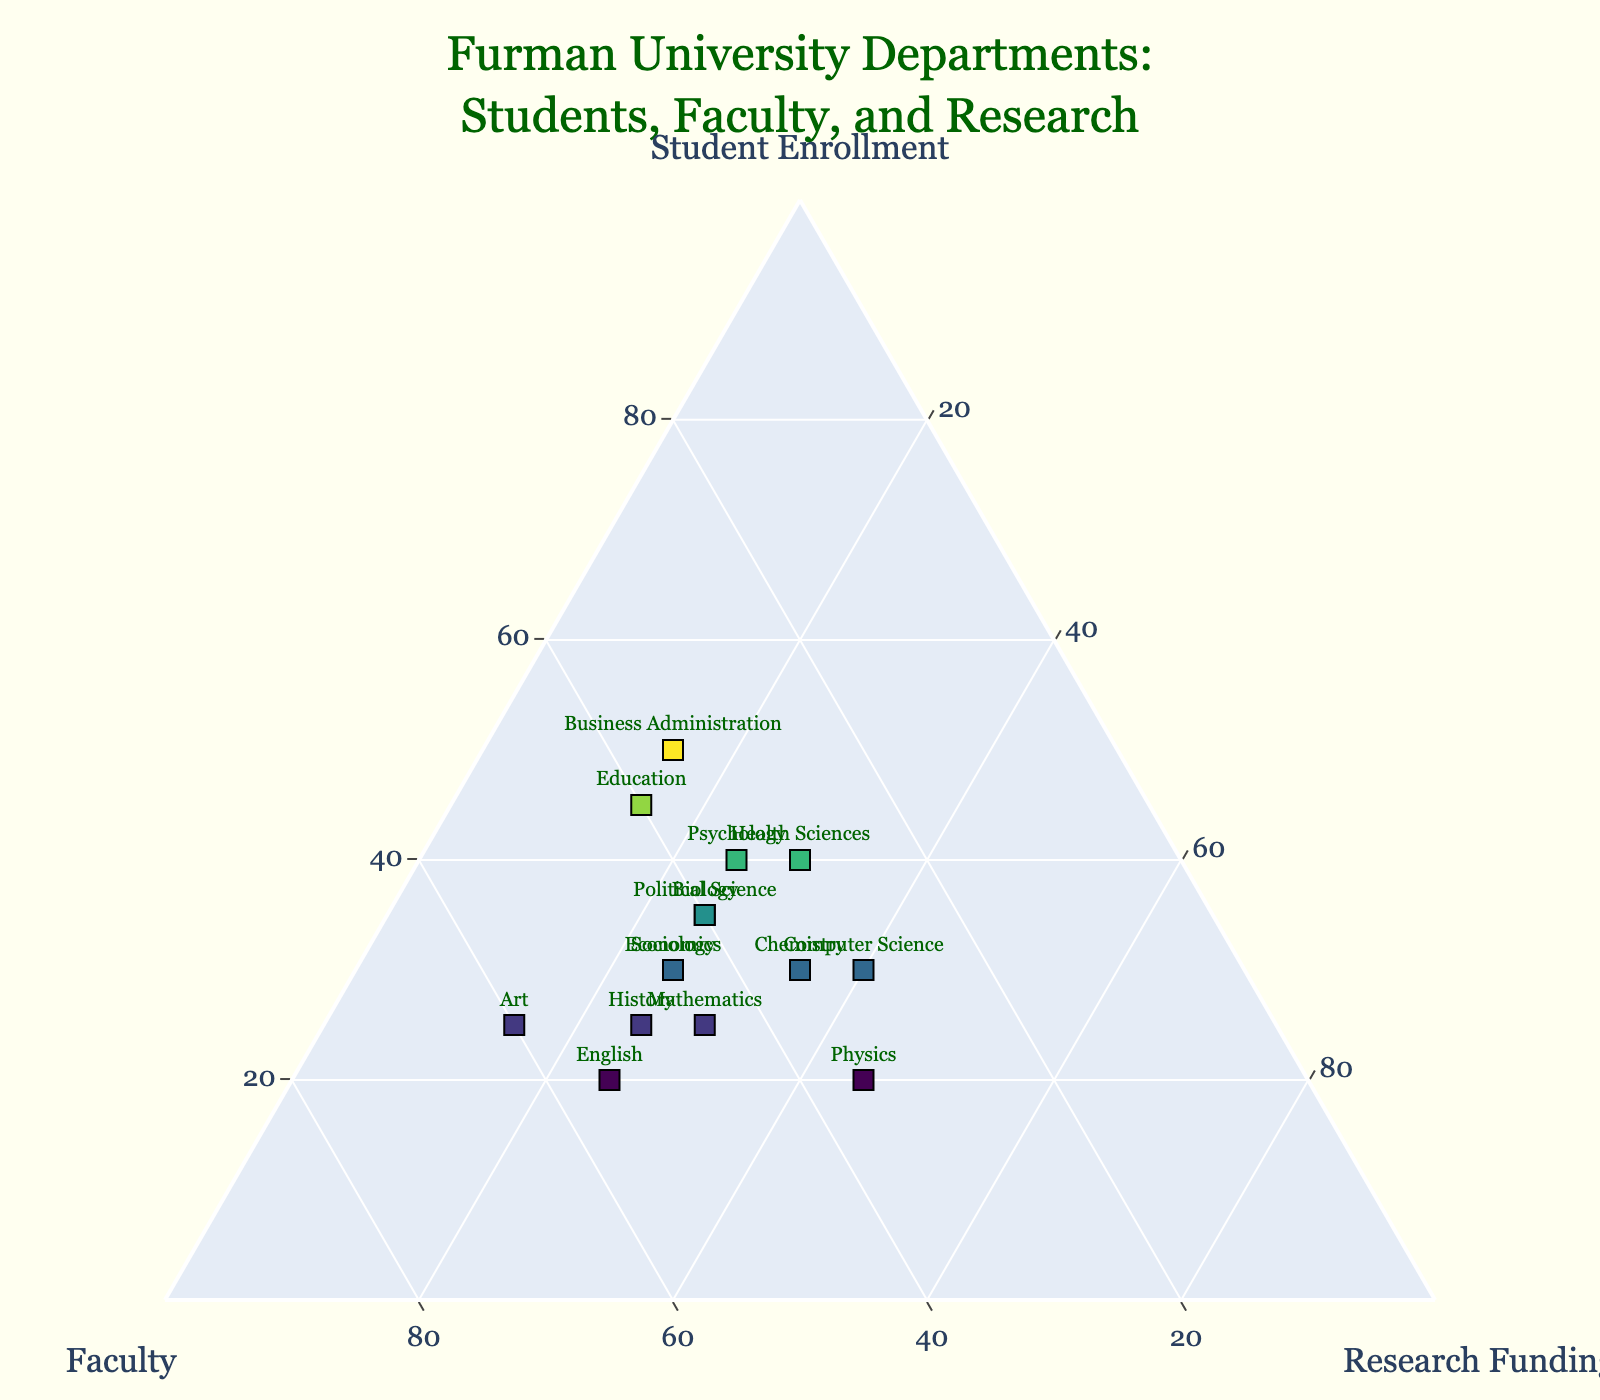what is the title of the figure? The title of the plot is displayed at the top and it typically represents the content and purpose of the figure. In this case, it is clearly written.
Answer: Furman University Departments: Students, Faculty, and Research How many departments are represented in the plot? Count the number of data points or department labels in the scatter plot to determine the total number of departments included.
Answer: 15 Which department has the lowest proportion of Research Funding? Identify the data point where the 'c' dimension (Research Funding) is at the lowest percentage relative to the other two dimensions.
Answer: Business Administration and Art Of all the departments, which one has the highest student enrollment? Locate the data point with the highest relative value along the 'Student Enrollment' axis, marked as 'a'.
Answer: Business Administration How does the faculty distribution compare between the Sociology and Health Sciences departments? Check the position along the 'Faculty' axis for both Sociology and Health Sciences, comparing their relative placements.
Answer: Sociology has a higher faculty proportion than Health Sciences What is the proportion of faculty in the Chemistry department? Find the Chemistry department's data point, and note its proportion along the 'Faculty' axis. Calculate from the normalized format.
Answer: 35% Which department has a balanced distribution across Student Enrollment, Faculty, and Research Funding? Look for a data point that is roughly equidistant from all three axes, indicating a balanced distribution.
Answer: Computer Science Between History and Economics, which department has a greater emphasis on Faculty? Compare the positions of History and Economics along the Faculty axis to determine which department has a higher proportion.
Answer: History What unique characteristics can be identified from the Political Science department in terms of Student Enrollment, Faculty, and Research Funding? Examine the specific data point for Political Science, and note its relative proportions along each of the three axes. Describe any notable balance or disparity.
Answer: Higher in Student Enrollment and Faculty, lower in Research Funding Is there a visible trend in departments with significant research funding? Observe the distribution of data points along the Research Funding axis and describe if any trend or pattern can be discerned regarding departments with higher research funding.
Answer: Limited to specific departments like Physics and Computer Science 